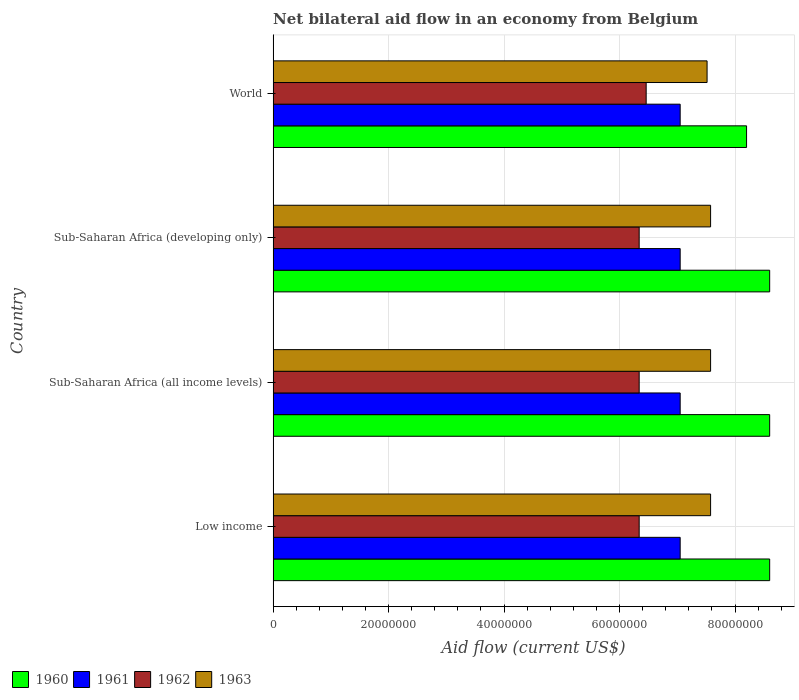How many different coloured bars are there?
Provide a short and direct response. 4. How many groups of bars are there?
Offer a terse response. 4. Are the number of bars per tick equal to the number of legend labels?
Your answer should be very brief. Yes. Are the number of bars on each tick of the Y-axis equal?
Your answer should be very brief. Yes. How many bars are there on the 4th tick from the top?
Offer a very short reply. 4. What is the label of the 4th group of bars from the top?
Your response must be concise. Low income. What is the net bilateral aid flow in 1961 in World?
Your answer should be compact. 7.05e+07. Across all countries, what is the maximum net bilateral aid flow in 1961?
Keep it short and to the point. 7.05e+07. Across all countries, what is the minimum net bilateral aid flow in 1960?
Your answer should be very brief. 8.20e+07. In which country was the net bilateral aid flow in 1963 maximum?
Give a very brief answer. Low income. What is the total net bilateral aid flow in 1961 in the graph?
Your answer should be very brief. 2.82e+08. What is the difference between the net bilateral aid flow in 1962 in Sub-Saharan Africa (all income levels) and the net bilateral aid flow in 1963 in World?
Give a very brief answer. -1.18e+07. What is the average net bilateral aid flow in 1963 per country?
Offer a very short reply. 7.56e+07. What is the difference between the net bilateral aid flow in 1962 and net bilateral aid flow in 1961 in World?
Give a very brief answer. -5.89e+06. What is the ratio of the net bilateral aid flow in 1962 in Low income to that in World?
Give a very brief answer. 0.98. Is the net bilateral aid flow in 1963 in Sub-Saharan Africa (all income levels) less than that in Sub-Saharan Africa (developing only)?
Your answer should be very brief. No. Is the difference between the net bilateral aid flow in 1962 in Low income and World greater than the difference between the net bilateral aid flow in 1961 in Low income and World?
Your answer should be very brief. No. What is the difference between the highest and the second highest net bilateral aid flow in 1962?
Your answer should be compact. 1.21e+06. Is the sum of the net bilateral aid flow in 1962 in Sub-Saharan Africa (all income levels) and World greater than the maximum net bilateral aid flow in 1961 across all countries?
Offer a terse response. Yes. Is it the case that in every country, the sum of the net bilateral aid flow in 1961 and net bilateral aid flow in 1960 is greater than the net bilateral aid flow in 1963?
Ensure brevity in your answer.  Yes. How many bars are there?
Your answer should be compact. 16. Does the graph contain any zero values?
Make the answer very short. No. Where does the legend appear in the graph?
Offer a very short reply. Bottom left. How are the legend labels stacked?
Offer a terse response. Horizontal. What is the title of the graph?
Offer a very short reply. Net bilateral aid flow in an economy from Belgium. What is the label or title of the X-axis?
Your answer should be very brief. Aid flow (current US$). What is the label or title of the Y-axis?
Provide a short and direct response. Country. What is the Aid flow (current US$) in 1960 in Low income?
Offer a very short reply. 8.60e+07. What is the Aid flow (current US$) of 1961 in Low income?
Your answer should be compact. 7.05e+07. What is the Aid flow (current US$) in 1962 in Low income?
Your answer should be very brief. 6.34e+07. What is the Aid flow (current US$) of 1963 in Low income?
Offer a terse response. 7.58e+07. What is the Aid flow (current US$) in 1960 in Sub-Saharan Africa (all income levels)?
Your answer should be compact. 8.60e+07. What is the Aid flow (current US$) of 1961 in Sub-Saharan Africa (all income levels)?
Give a very brief answer. 7.05e+07. What is the Aid flow (current US$) in 1962 in Sub-Saharan Africa (all income levels)?
Your answer should be compact. 6.34e+07. What is the Aid flow (current US$) in 1963 in Sub-Saharan Africa (all income levels)?
Offer a terse response. 7.58e+07. What is the Aid flow (current US$) of 1960 in Sub-Saharan Africa (developing only)?
Your answer should be very brief. 8.60e+07. What is the Aid flow (current US$) in 1961 in Sub-Saharan Africa (developing only)?
Provide a short and direct response. 7.05e+07. What is the Aid flow (current US$) in 1962 in Sub-Saharan Africa (developing only)?
Keep it short and to the point. 6.34e+07. What is the Aid flow (current US$) in 1963 in Sub-Saharan Africa (developing only)?
Provide a succinct answer. 7.58e+07. What is the Aid flow (current US$) in 1960 in World?
Your answer should be very brief. 8.20e+07. What is the Aid flow (current US$) in 1961 in World?
Make the answer very short. 7.05e+07. What is the Aid flow (current US$) in 1962 in World?
Make the answer very short. 6.46e+07. What is the Aid flow (current US$) in 1963 in World?
Keep it short and to the point. 7.52e+07. Across all countries, what is the maximum Aid flow (current US$) in 1960?
Your answer should be compact. 8.60e+07. Across all countries, what is the maximum Aid flow (current US$) in 1961?
Keep it short and to the point. 7.05e+07. Across all countries, what is the maximum Aid flow (current US$) of 1962?
Make the answer very short. 6.46e+07. Across all countries, what is the maximum Aid flow (current US$) of 1963?
Give a very brief answer. 7.58e+07. Across all countries, what is the minimum Aid flow (current US$) in 1960?
Make the answer very short. 8.20e+07. Across all countries, what is the minimum Aid flow (current US$) in 1961?
Make the answer very short. 7.05e+07. Across all countries, what is the minimum Aid flow (current US$) of 1962?
Your response must be concise. 6.34e+07. Across all countries, what is the minimum Aid flow (current US$) in 1963?
Provide a succinct answer. 7.52e+07. What is the total Aid flow (current US$) in 1960 in the graph?
Make the answer very short. 3.40e+08. What is the total Aid flow (current US$) in 1961 in the graph?
Make the answer very short. 2.82e+08. What is the total Aid flow (current US$) in 1962 in the graph?
Offer a terse response. 2.55e+08. What is the total Aid flow (current US$) of 1963 in the graph?
Keep it short and to the point. 3.02e+08. What is the difference between the Aid flow (current US$) in 1962 in Low income and that in Sub-Saharan Africa (all income levels)?
Your response must be concise. 0. What is the difference between the Aid flow (current US$) of 1963 in Low income and that in Sub-Saharan Africa (all income levels)?
Your response must be concise. 0. What is the difference between the Aid flow (current US$) of 1960 in Low income and that in Sub-Saharan Africa (developing only)?
Make the answer very short. 0. What is the difference between the Aid flow (current US$) in 1961 in Low income and that in Sub-Saharan Africa (developing only)?
Make the answer very short. 0. What is the difference between the Aid flow (current US$) of 1962 in Low income and that in Sub-Saharan Africa (developing only)?
Your answer should be very brief. 0. What is the difference between the Aid flow (current US$) of 1963 in Low income and that in Sub-Saharan Africa (developing only)?
Your response must be concise. 0. What is the difference between the Aid flow (current US$) of 1962 in Low income and that in World?
Your response must be concise. -1.21e+06. What is the difference between the Aid flow (current US$) in 1961 in Sub-Saharan Africa (all income levels) and that in Sub-Saharan Africa (developing only)?
Provide a succinct answer. 0. What is the difference between the Aid flow (current US$) of 1961 in Sub-Saharan Africa (all income levels) and that in World?
Your answer should be compact. 0. What is the difference between the Aid flow (current US$) in 1962 in Sub-Saharan Africa (all income levels) and that in World?
Offer a very short reply. -1.21e+06. What is the difference between the Aid flow (current US$) of 1961 in Sub-Saharan Africa (developing only) and that in World?
Offer a very short reply. 0. What is the difference between the Aid flow (current US$) of 1962 in Sub-Saharan Africa (developing only) and that in World?
Offer a terse response. -1.21e+06. What is the difference between the Aid flow (current US$) in 1960 in Low income and the Aid flow (current US$) in 1961 in Sub-Saharan Africa (all income levels)?
Offer a terse response. 1.55e+07. What is the difference between the Aid flow (current US$) in 1960 in Low income and the Aid flow (current US$) in 1962 in Sub-Saharan Africa (all income levels)?
Offer a terse response. 2.26e+07. What is the difference between the Aid flow (current US$) in 1960 in Low income and the Aid flow (current US$) in 1963 in Sub-Saharan Africa (all income levels)?
Your answer should be compact. 1.02e+07. What is the difference between the Aid flow (current US$) in 1961 in Low income and the Aid flow (current US$) in 1962 in Sub-Saharan Africa (all income levels)?
Give a very brief answer. 7.10e+06. What is the difference between the Aid flow (current US$) in 1961 in Low income and the Aid flow (current US$) in 1963 in Sub-Saharan Africa (all income levels)?
Offer a very short reply. -5.27e+06. What is the difference between the Aid flow (current US$) of 1962 in Low income and the Aid flow (current US$) of 1963 in Sub-Saharan Africa (all income levels)?
Your answer should be very brief. -1.24e+07. What is the difference between the Aid flow (current US$) in 1960 in Low income and the Aid flow (current US$) in 1961 in Sub-Saharan Africa (developing only)?
Give a very brief answer. 1.55e+07. What is the difference between the Aid flow (current US$) in 1960 in Low income and the Aid flow (current US$) in 1962 in Sub-Saharan Africa (developing only)?
Offer a very short reply. 2.26e+07. What is the difference between the Aid flow (current US$) of 1960 in Low income and the Aid flow (current US$) of 1963 in Sub-Saharan Africa (developing only)?
Provide a short and direct response. 1.02e+07. What is the difference between the Aid flow (current US$) in 1961 in Low income and the Aid flow (current US$) in 1962 in Sub-Saharan Africa (developing only)?
Offer a terse response. 7.10e+06. What is the difference between the Aid flow (current US$) in 1961 in Low income and the Aid flow (current US$) in 1963 in Sub-Saharan Africa (developing only)?
Ensure brevity in your answer.  -5.27e+06. What is the difference between the Aid flow (current US$) of 1962 in Low income and the Aid flow (current US$) of 1963 in Sub-Saharan Africa (developing only)?
Ensure brevity in your answer.  -1.24e+07. What is the difference between the Aid flow (current US$) in 1960 in Low income and the Aid flow (current US$) in 1961 in World?
Your answer should be compact. 1.55e+07. What is the difference between the Aid flow (current US$) of 1960 in Low income and the Aid flow (current US$) of 1962 in World?
Ensure brevity in your answer.  2.14e+07. What is the difference between the Aid flow (current US$) of 1960 in Low income and the Aid flow (current US$) of 1963 in World?
Your answer should be compact. 1.08e+07. What is the difference between the Aid flow (current US$) of 1961 in Low income and the Aid flow (current US$) of 1962 in World?
Keep it short and to the point. 5.89e+06. What is the difference between the Aid flow (current US$) of 1961 in Low income and the Aid flow (current US$) of 1963 in World?
Offer a terse response. -4.66e+06. What is the difference between the Aid flow (current US$) of 1962 in Low income and the Aid flow (current US$) of 1963 in World?
Your answer should be very brief. -1.18e+07. What is the difference between the Aid flow (current US$) in 1960 in Sub-Saharan Africa (all income levels) and the Aid flow (current US$) in 1961 in Sub-Saharan Africa (developing only)?
Your response must be concise. 1.55e+07. What is the difference between the Aid flow (current US$) of 1960 in Sub-Saharan Africa (all income levels) and the Aid flow (current US$) of 1962 in Sub-Saharan Africa (developing only)?
Your answer should be very brief. 2.26e+07. What is the difference between the Aid flow (current US$) in 1960 in Sub-Saharan Africa (all income levels) and the Aid flow (current US$) in 1963 in Sub-Saharan Africa (developing only)?
Your response must be concise. 1.02e+07. What is the difference between the Aid flow (current US$) of 1961 in Sub-Saharan Africa (all income levels) and the Aid flow (current US$) of 1962 in Sub-Saharan Africa (developing only)?
Make the answer very short. 7.10e+06. What is the difference between the Aid flow (current US$) in 1961 in Sub-Saharan Africa (all income levels) and the Aid flow (current US$) in 1963 in Sub-Saharan Africa (developing only)?
Offer a terse response. -5.27e+06. What is the difference between the Aid flow (current US$) in 1962 in Sub-Saharan Africa (all income levels) and the Aid flow (current US$) in 1963 in Sub-Saharan Africa (developing only)?
Your answer should be compact. -1.24e+07. What is the difference between the Aid flow (current US$) in 1960 in Sub-Saharan Africa (all income levels) and the Aid flow (current US$) in 1961 in World?
Ensure brevity in your answer.  1.55e+07. What is the difference between the Aid flow (current US$) of 1960 in Sub-Saharan Africa (all income levels) and the Aid flow (current US$) of 1962 in World?
Provide a short and direct response. 2.14e+07. What is the difference between the Aid flow (current US$) of 1960 in Sub-Saharan Africa (all income levels) and the Aid flow (current US$) of 1963 in World?
Provide a short and direct response. 1.08e+07. What is the difference between the Aid flow (current US$) in 1961 in Sub-Saharan Africa (all income levels) and the Aid flow (current US$) in 1962 in World?
Ensure brevity in your answer.  5.89e+06. What is the difference between the Aid flow (current US$) of 1961 in Sub-Saharan Africa (all income levels) and the Aid flow (current US$) of 1963 in World?
Your answer should be very brief. -4.66e+06. What is the difference between the Aid flow (current US$) in 1962 in Sub-Saharan Africa (all income levels) and the Aid flow (current US$) in 1963 in World?
Provide a short and direct response. -1.18e+07. What is the difference between the Aid flow (current US$) in 1960 in Sub-Saharan Africa (developing only) and the Aid flow (current US$) in 1961 in World?
Your response must be concise. 1.55e+07. What is the difference between the Aid flow (current US$) in 1960 in Sub-Saharan Africa (developing only) and the Aid flow (current US$) in 1962 in World?
Offer a terse response. 2.14e+07. What is the difference between the Aid flow (current US$) of 1960 in Sub-Saharan Africa (developing only) and the Aid flow (current US$) of 1963 in World?
Offer a very short reply. 1.08e+07. What is the difference between the Aid flow (current US$) of 1961 in Sub-Saharan Africa (developing only) and the Aid flow (current US$) of 1962 in World?
Your response must be concise. 5.89e+06. What is the difference between the Aid flow (current US$) in 1961 in Sub-Saharan Africa (developing only) and the Aid flow (current US$) in 1963 in World?
Offer a very short reply. -4.66e+06. What is the difference between the Aid flow (current US$) in 1962 in Sub-Saharan Africa (developing only) and the Aid flow (current US$) in 1963 in World?
Keep it short and to the point. -1.18e+07. What is the average Aid flow (current US$) in 1960 per country?
Your answer should be very brief. 8.50e+07. What is the average Aid flow (current US$) in 1961 per country?
Offer a terse response. 7.05e+07. What is the average Aid flow (current US$) of 1962 per country?
Provide a short and direct response. 6.37e+07. What is the average Aid flow (current US$) in 1963 per country?
Offer a very short reply. 7.56e+07. What is the difference between the Aid flow (current US$) of 1960 and Aid flow (current US$) of 1961 in Low income?
Your answer should be very brief. 1.55e+07. What is the difference between the Aid flow (current US$) in 1960 and Aid flow (current US$) in 1962 in Low income?
Your answer should be compact. 2.26e+07. What is the difference between the Aid flow (current US$) in 1960 and Aid flow (current US$) in 1963 in Low income?
Provide a short and direct response. 1.02e+07. What is the difference between the Aid flow (current US$) of 1961 and Aid flow (current US$) of 1962 in Low income?
Keep it short and to the point. 7.10e+06. What is the difference between the Aid flow (current US$) in 1961 and Aid flow (current US$) in 1963 in Low income?
Keep it short and to the point. -5.27e+06. What is the difference between the Aid flow (current US$) of 1962 and Aid flow (current US$) of 1963 in Low income?
Your response must be concise. -1.24e+07. What is the difference between the Aid flow (current US$) of 1960 and Aid flow (current US$) of 1961 in Sub-Saharan Africa (all income levels)?
Provide a succinct answer. 1.55e+07. What is the difference between the Aid flow (current US$) in 1960 and Aid flow (current US$) in 1962 in Sub-Saharan Africa (all income levels)?
Provide a succinct answer. 2.26e+07. What is the difference between the Aid flow (current US$) in 1960 and Aid flow (current US$) in 1963 in Sub-Saharan Africa (all income levels)?
Your response must be concise. 1.02e+07. What is the difference between the Aid flow (current US$) in 1961 and Aid flow (current US$) in 1962 in Sub-Saharan Africa (all income levels)?
Provide a succinct answer. 7.10e+06. What is the difference between the Aid flow (current US$) of 1961 and Aid flow (current US$) of 1963 in Sub-Saharan Africa (all income levels)?
Offer a terse response. -5.27e+06. What is the difference between the Aid flow (current US$) in 1962 and Aid flow (current US$) in 1963 in Sub-Saharan Africa (all income levels)?
Provide a short and direct response. -1.24e+07. What is the difference between the Aid flow (current US$) of 1960 and Aid flow (current US$) of 1961 in Sub-Saharan Africa (developing only)?
Provide a short and direct response. 1.55e+07. What is the difference between the Aid flow (current US$) of 1960 and Aid flow (current US$) of 1962 in Sub-Saharan Africa (developing only)?
Your answer should be very brief. 2.26e+07. What is the difference between the Aid flow (current US$) of 1960 and Aid flow (current US$) of 1963 in Sub-Saharan Africa (developing only)?
Your response must be concise. 1.02e+07. What is the difference between the Aid flow (current US$) in 1961 and Aid flow (current US$) in 1962 in Sub-Saharan Africa (developing only)?
Ensure brevity in your answer.  7.10e+06. What is the difference between the Aid flow (current US$) of 1961 and Aid flow (current US$) of 1963 in Sub-Saharan Africa (developing only)?
Provide a short and direct response. -5.27e+06. What is the difference between the Aid flow (current US$) in 1962 and Aid flow (current US$) in 1963 in Sub-Saharan Africa (developing only)?
Keep it short and to the point. -1.24e+07. What is the difference between the Aid flow (current US$) of 1960 and Aid flow (current US$) of 1961 in World?
Provide a succinct answer. 1.15e+07. What is the difference between the Aid flow (current US$) of 1960 and Aid flow (current US$) of 1962 in World?
Ensure brevity in your answer.  1.74e+07. What is the difference between the Aid flow (current US$) of 1960 and Aid flow (current US$) of 1963 in World?
Your response must be concise. 6.84e+06. What is the difference between the Aid flow (current US$) of 1961 and Aid flow (current US$) of 1962 in World?
Provide a short and direct response. 5.89e+06. What is the difference between the Aid flow (current US$) in 1961 and Aid flow (current US$) in 1963 in World?
Provide a short and direct response. -4.66e+06. What is the difference between the Aid flow (current US$) in 1962 and Aid flow (current US$) in 1963 in World?
Provide a succinct answer. -1.06e+07. What is the ratio of the Aid flow (current US$) of 1961 in Low income to that in Sub-Saharan Africa (all income levels)?
Keep it short and to the point. 1. What is the ratio of the Aid flow (current US$) of 1962 in Low income to that in Sub-Saharan Africa (all income levels)?
Ensure brevity in your answer.  1. What is the ratio of the Aid flow (current US$) in 1960 in Low income to that in Sub-Saharan Africa (developing only)?
Provide a short and direct response. 1. What is the ratio of the Aid flow (current US$) of 1961 in Low income to that in Sub-Saharan Africa (developing only)?
Provide a short and direct response. 1. What is the ratio of the Aid flow (current US$) in 1960 in Low income to that in World?
Your response must be concise. 1.05. What is the ratio of the Aid flow (current US$) in 1961 in Low income to that in World?
Give a very brief answer. 1. What is the ratio of the Aid flow (current US$) in 1962 in Low income to that in World?
Your answer should be very brief. 0.98. What is the ratio of the Aid flow (current US$) of 1963 in Low income to that in World?
Offer a terse response. 1.01. What is the ratio of the Aid flow (current US$) in 1961 in Sub-Saharan Africa (all income levels) to that in Sub-Saharan Africa (developing only)?
Provide a succinct answer. 1. What is the ratio of the Aid flow (current US$) of 1960 in Sub-Saharan Africa (all income levels) to that in World?
Offer a terse response. 1.05. What is the ratio of the Aid flow (current US$) of 1961 in Sub-Saharan Africa (all income levels) to that in World?
Your answer should be compact. 1. What is the ratio of the Aid flow (current US$) in 1962 in Sub-Saharan Africa (all income levels) to that in World?
Keep it short and to the point. 0.98. What is the ratio of the Aid flow (current US$) of 1963 in Sub-Saharan Africa (all income levels) to that in World?
Your response must be concise. 1.01. What is the ratio of the Aid flow (current US$) of 1960 in Sub-Saharan Africa (developing only) to that in World?
Your answer should be very brief. 1.05. What is the ratio of the Aid flow (current US$) in 1961 in Sub-Saharan Africa (developing only) to that in World?
Keep it short and to the point. 1. What is the ratio of the Aid flow (current US$) in 1962 in Sub-Saharan Africa (developing only) to that in World?
Make the answer very short. 0.98. What is the difference between the highest and the second highest Aid flow (current US$) in 1962?
Your response must be concise. 1.21e+06. What is the difference between the highest and the second highest Aid flow (current US$) of 1963?
Keep it short and to the point. 0. What is the difference between the highest and the lowest Aid flow (current US$) of 1960?
Your answer should be compact. 4.00e+06. What is the difference between the highest and the lowest Aid flow (current US$) in 1961?
Ensure brevity in your answer.  0. What is the difference between the highest and the lowest Aid flow (current US$) in 1962?
Your answer should be compact. 1.21e+06. What is the difference between the highest and the lowest Aid flow (current US$) in 1963?
Your response must be concise. 6.10e+05. 